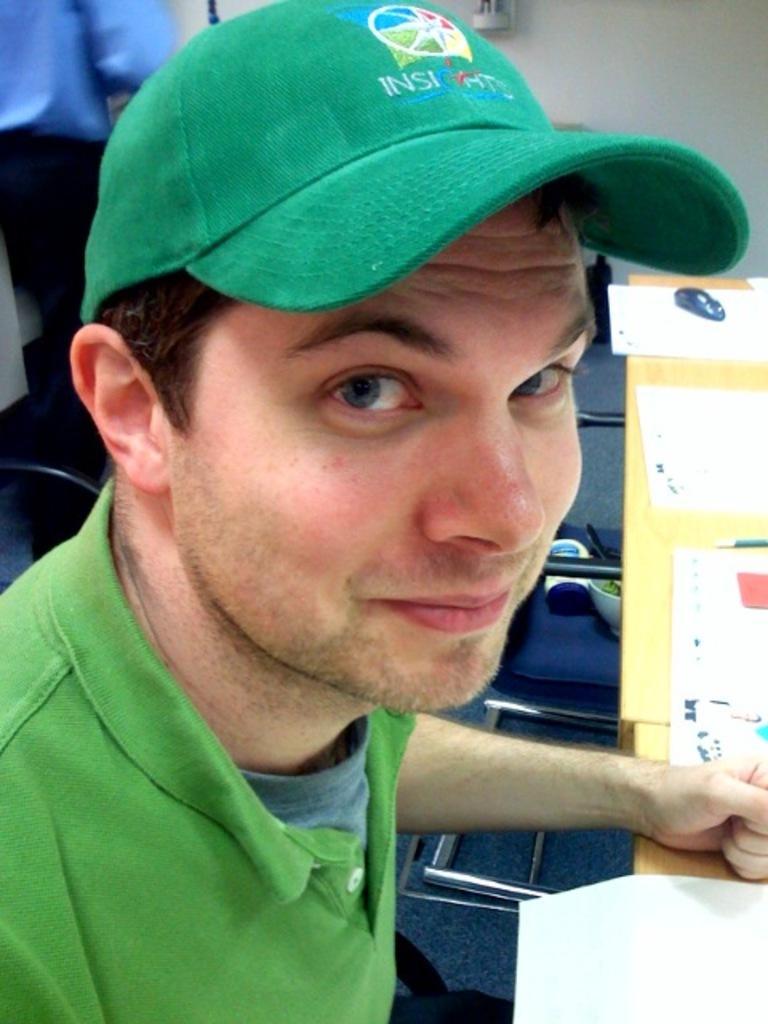How would you summarize this image in a sentence or two? In this picture we can see a man in the front, he wore a green color t-shirt and green color cap, on the right side there is a table, we can see some papers present on the table, in the background there is a wall, we can see another person at the left top of the picture. 